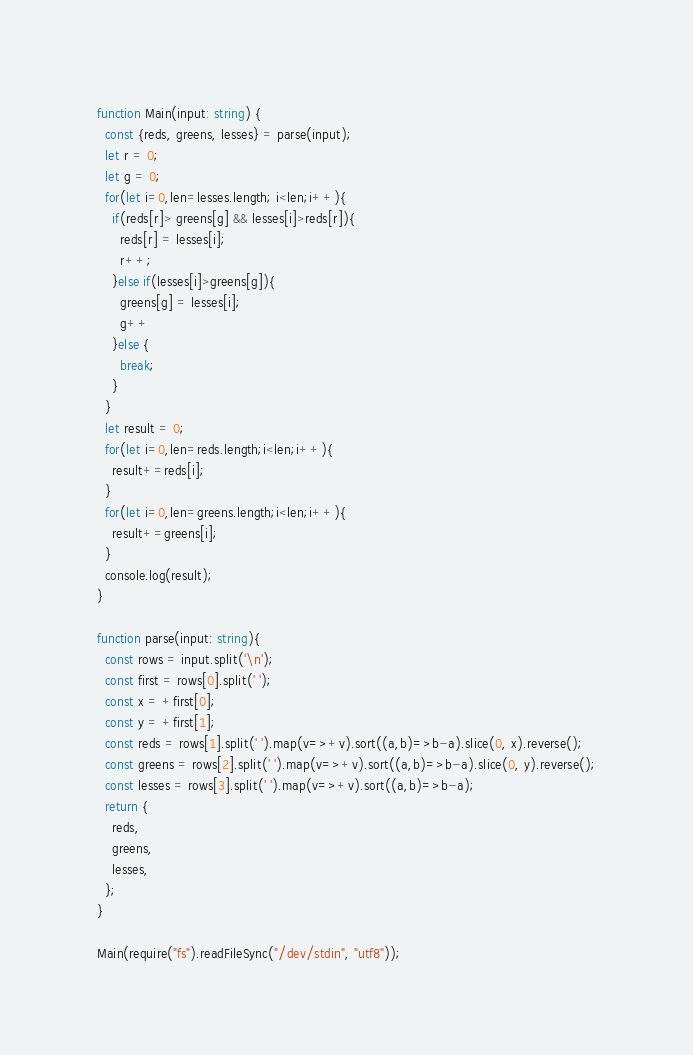<code> <loc_0><loc_0><loc_500><loc_500><_TypeScript_>function Main(input: string) {
  const {reds, greens, lesses} = parse(input);
  let r = 0;
  let g = 0;
  for(let i=0,len=lesses.length; i<len;i++){
    if(reds[r]> greens[g] && lesses[i]>reds[r]){
      reds[r] = lesses[i];
      r++;
    }else if(lesses[i]>greens[g]){
      greens[g] = lesses[i];
      g++
    }else {
      break;
    }
  }
  let result = 0;
  for(let i=0,len=reds.length;i<len;i++){
    result+=reds[i];
  }
  for(let i=0,len=greens.length;i<len;i++){
    result+=greens[i];
  }
  console.log(result);
}

function parse(input: string){
  const rows = input.split('\n');
  const first = rows[0].split(' ');
  const x = +first[0];
  const y = +first[1];
  const reds = rows[1].split(' ').map(v=>+v).sort((a,b)=>b-a).slice(0, x).reverse();
  const greens = rows[2].split(' ').map(v=>+v).sort((a,b)=>b-a).slice(0, y).reverse();
  const lesses = rows[3].split(' ').map(v=>+v).sort((a,b)=>b-a);
  return {
    reds,
    greens,
    lesses,
  };
}

Main(require("fs").readFileSync("/dev/stdin", "utf8"));
</code> 